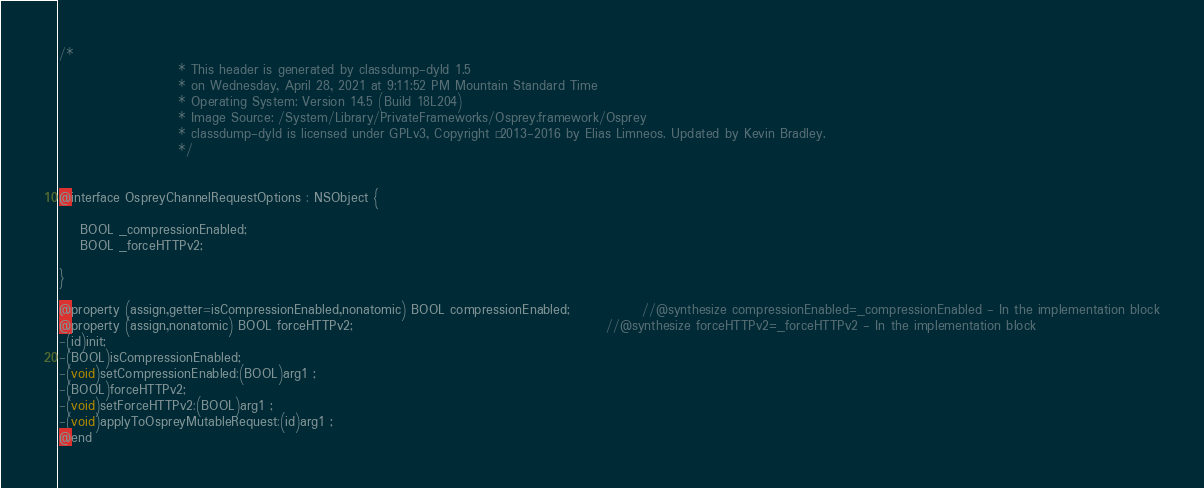Convert code to text. <code><loc_0><loc_0><loc_500><loc_500><_C_>/*
                       * This header is generated by classdump-dyld 1.5
                       * on Wednesday, April 28, 2021 at 9:11:52 PM Mountain Standard Time
                       * Operating System: Version 14.5 (Build 18L204)
                       * Image Source: /System/Library/PrivateFrameworks/Osprey.framework/Osprey
                       * classdump-dyld is licensed under GPLv3, Copyright © 2013-2016 by Elias Limneos. Updated by Kevin Bradley.
                       */


@interface OspreyChannelRequestOptions : NSObject {

	BOOL _compressionEnabled;
	BOOL _forceHTTPv2;

}

@property (assign,getter=isCompressionEnabled,nonatomic) BOOL compressionEnabled;              //@synthesize compressionEnabled=_compressionEnabled - In the implementation block
@property (assign,nonatomic) BOOL forceHTTPv2;                                                 //@synthesize forceHTTPv2=_forceHTTPv2 - In the implementation block
-(id)init;
-(BOOL)isCompressionEnabled;
-(void)setCompressionEnabled:(BOOL)arg1 ;
-(BOOL)forceHTTPv2;
-(void)setForceHTTPv2:(BOOL)arg1 ;
-(void)applyToOspreyMutableRequest:(id)arg1 ;
@end

</code> 